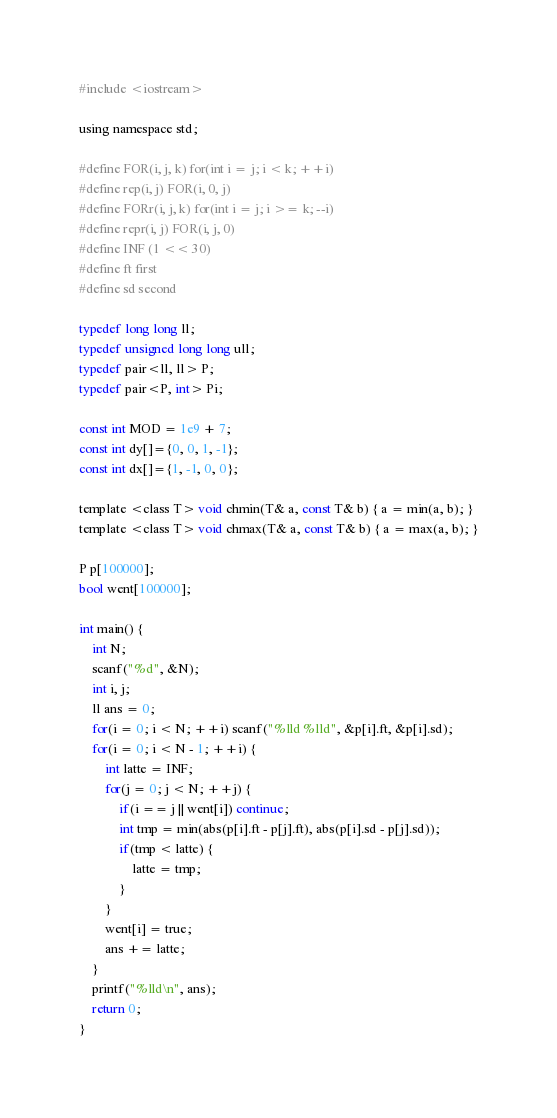Convert code to text. <code><loc_0><loc_0><loc_500><loc_500><_C_>#include <iostream>  

using namespace std;

#define FOR(i, j, k) for(int i = j; i < k; ++i)
#define rep(i, j) FOR(i, 0, j)
#define FORr(i, j, k) for(int i = j; i >= k; --i)
#define repr(i, j) FOR(i, j, 0)
#define INF (1 << 30)
#define ft first
#define sd second

typedef long long ll;
typedef unsigned long long ull;
typedef pair<ll, ll> P;
typedef pair<P, int> Pi;

const int MOD = 1e9 + 7;
const int dy[]={0, 0, 1, -1};
const int dx[]={1, -1, 0, 0};

template <class T> void chmin(T& a, const T& b) { a = min(a, b); }
template <class T> void chmax(T& a, const T& b) { a = max(a, b); }

P p[100000];
bool went[100000];

int main() {
	int N;
	scanf("%d", &N);
	int i, j;
	ll ans = 0;
	for(i = 0; i < N; ++i) scanf("%lld %lld", &p[i].ft, &p[i].sd);
	for(i = 0; i < N - 1; ++i) {
		int latte = INF;
		for(j = 0; j < N; ++j) {
			if(i == j || went[i]) continue;
			int tmp = min(abs(p[i].ft - p[j].ft), abs(p[i].sd - p[j].sd));
			if(tmp < latte) {
				latte = tmp;
			}
		}
		went[i] = true;
		ans += latte;
	}
	printf("%lld\n", ans);
	return 0;
}</code> 